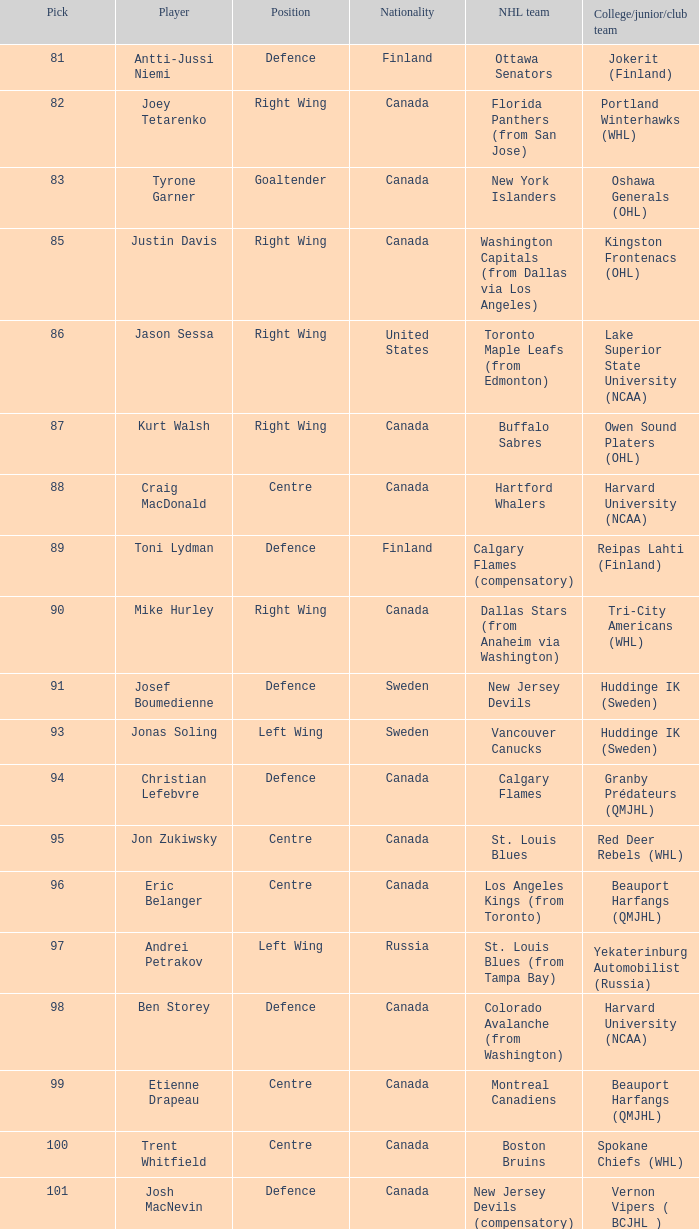What is the nationality of Christian Lefebvre? Canada. 